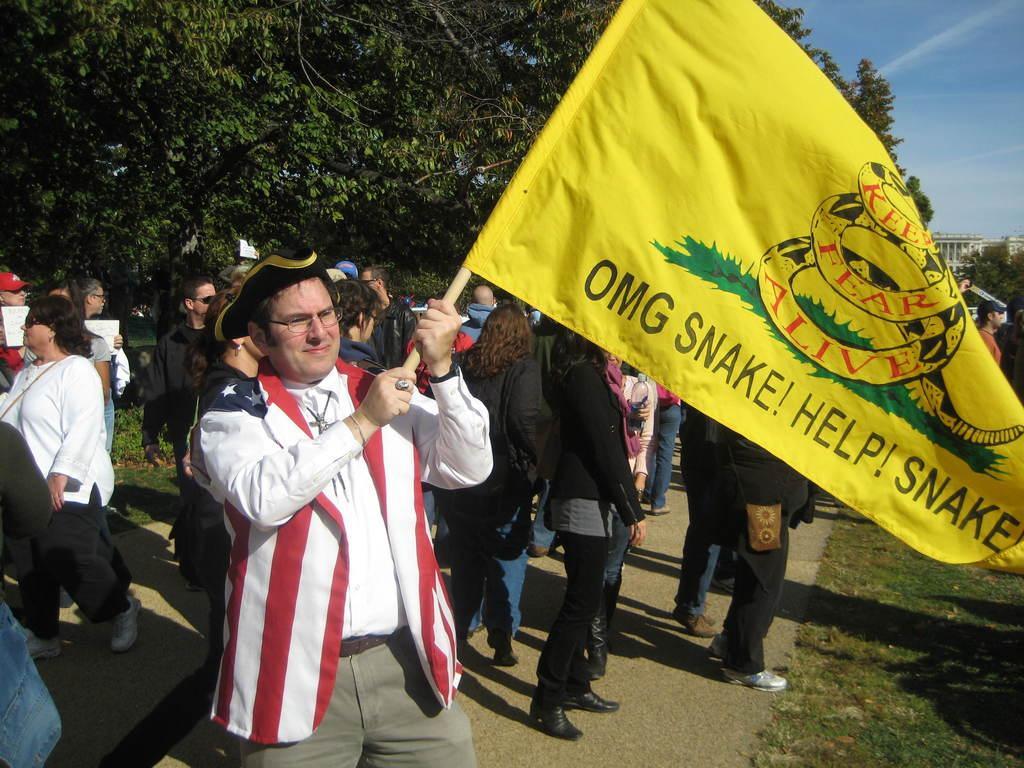Can you describe this image briefly? In the middle of the image a man is standing and smiling and holding a flag. Behind him few people are standing. Bottom right side of the image there is grass. Top right side of the image there are some buildings. Behind the buildings there are some clouds and sky. Top left side of the image there are some trees. 